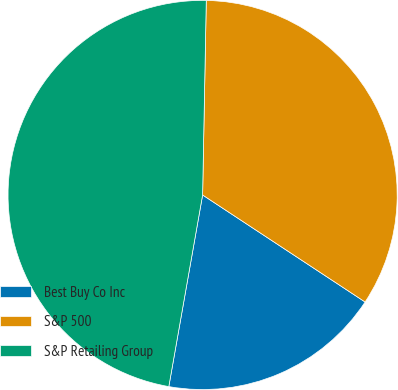Convert chart. <chart><loc_0><loc_0><loc_500><loc_500><pie_chart><fcel>Best Buy Co Inc<fcel>S&P 500<fcel>S&P Retailing Group<nl><fcel>18.51%<fcel>33.97%<fcel>47.52%<nl></chart> 